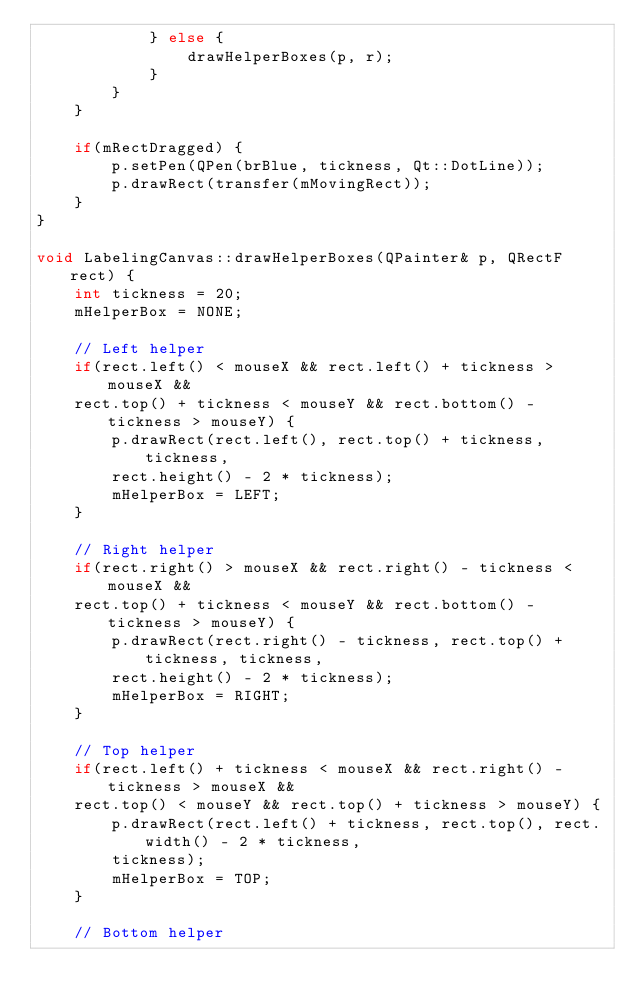Convert code to text. <code><loc_0><loc_0><loc_500><loc_500><_C++_>            } else {
                drawHelperBoxes(p, r);
            }
        }
    }
    
    if(mRectDragged) {
        p.setPen(QPen(brBlue, tickness, Qt::DotLine));
        p.drawRect(transfer(mMovingRect));
    }
}

void LabelingCanvas::drawHelperBoxes(QPainter& p, QRectF rect) {
    int tickness = 20;
    mHelperBox = NONE;
    
    // Left helper
    if(rect.left() < mouseX && rect.left() + tickness > mouseX &&
    rect.top() + tickness < mouseY && rect.bottom() - tickness > mouseY) {
        p.drawRect(rect.left(), rect.top() + tickness, tickness, 
        rect.height() - 2 * tickness);
        mHelperBox = LEFT;
    }
    
    // Right helper
    if(rect.right() > mouseX && rect.right() - tickness < mouseX &&
    rect.top() + tickness < mouseY && rect.bottom() - tickness > mouseY) {
        p.drawRect(rect.right() - tickness, rect.top() + tickness, tickness, 
        rect.height() - 2 * tickness);
        mHelperBox = RIGHT;
    }
    
    // Top helper
    if(rect.left() + tickness < mouseX && rect.right() - tickness > mouseX &&
    rect.top() < mouseY && rect.top() + tickness > mouseY) {
        p.drawRect(rect.left() + tickness, rect.top(), rect.width() - 2 * tickness, 
        tickness);
        mHelperBox = TOP;
    }

    // Bottom helper</code> 